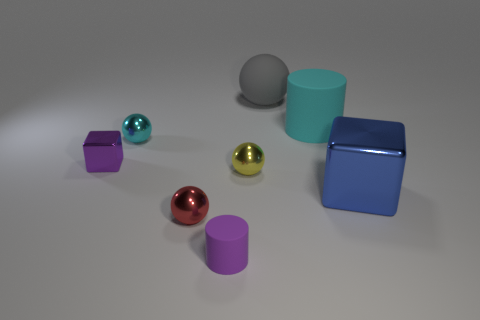Subtract all yellow spheres. Subtract all brown cylinders. How many spheres are left? 3 Subtract all purple cylinders. How many blue blocks are left? 1 Add 8 cyans. How many objects exist? 0 Subtract all small cyan shiny objects. Subtract all small cyan shiny objects. How many objects are left? 6 Add 2 yellow balls. How many yellow balls are left? 3 Add 3 large blocks. How many large blocks exist? 4 Add 1 small cyan spheres. How many objects exist? 9 Subtract all cyan cylinders. How many cylinders are left? 1 Subtract all gray matte spheres. How many spheres are left? 3 Subtract 0 brown balls. How many objects are left? 8 